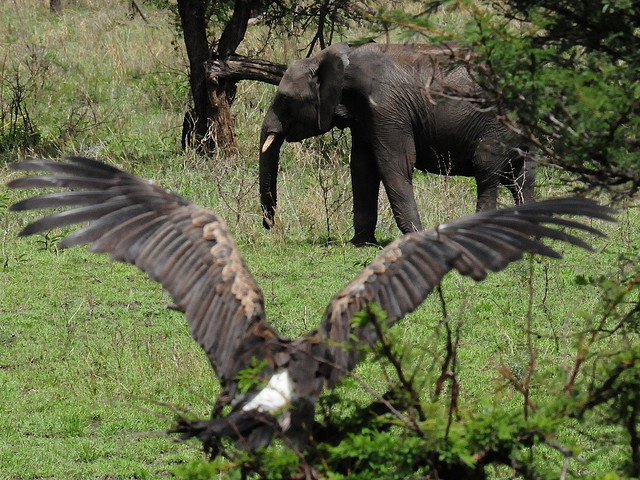Describe the objects in this image and their specific colors. I can see bird in tan, gray, black, darkgreen, and darkgray tones and elephant in tan, black, and gray tones in this image. 